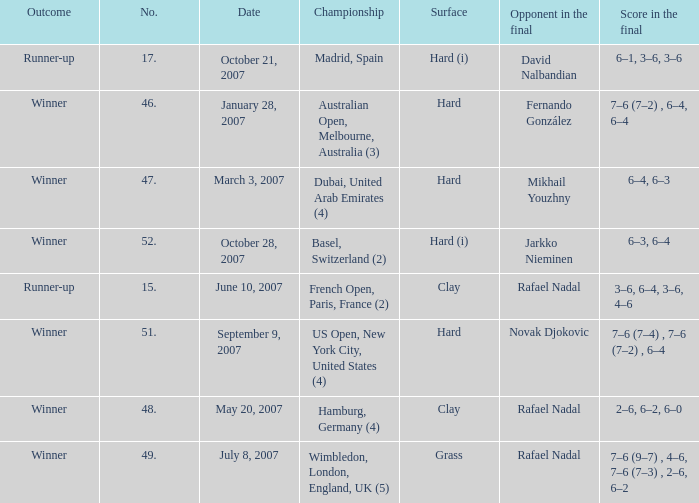Where the outcome is Winner and surface is Hard (i), what is the No.? 52.0. 